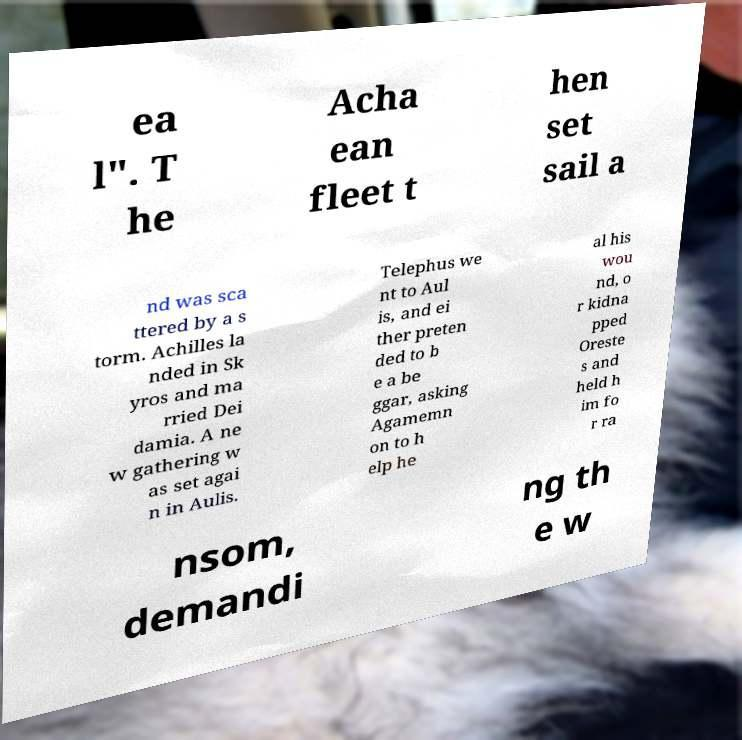Please identify and transcribe the text found in this image. ea l". T he Acha ean fleet t hen set sail a nd was sca ttered by a s torm. Achilles la nded in Sk yros and ma rried Dei damia. A ne w gathering w as set agai n in Aulis. Telephus we nt to Aul is, and ei ther preten ded to b e a be ggar, asking Agamemn on to h elp he al his wou nd, o r kidna pped Oreste s and held h im fo r ra nsom, demandi ng th e w 